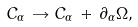Convert formula to latex. <formula><loc_0><loc_0><loc_500><loc_500>C _ { \alpha } \, \rightarrow C _ { \alpha } \, + \, \partial _ { \alpha } \Omega ,</formula> 